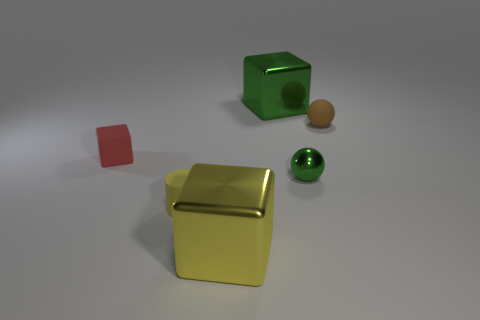There is another thing that is the same shape as the brown matte object; what is its size?
Provide a short and direct response. Small. How many other brown spheres are made of the same material as the small brown sphere?
Provide a succinct answer. 0. Is the number of brown rubber spheres left of the brown thing less than the number of brown spheres?
Offer a terse response. Yes. How many small cylinders are there?
Provide a succinct answer. 1. What number of objects have the same color as the tiny metal ball?
Give a very brief answer. 1. Is the shape of the large green object the same as the small green metal object?
Provide a succinct answer. No. There is a yellow thing left of the cube that is in front of the small red matte cube; what size is it?
Make the answer very short. Small. Is there another ball of the same size as the rubber sphere?
Ensure brevity in your answer.  Yes. Do the yellow object right of the tiny yellow cylinder and the brown ball behind the big yellow cube have the same size?
Your answer should be compact. No. The yellow thing that is behind the large metallic cube that is in front of the red matte object is what shape?
Offer a very short reply. Cylinder. 